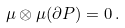<formula> <loc_0><loc_0><loc_500><loc_500>\mu \otimes \mu ( \partial P ) = 0 \, .</formula> 